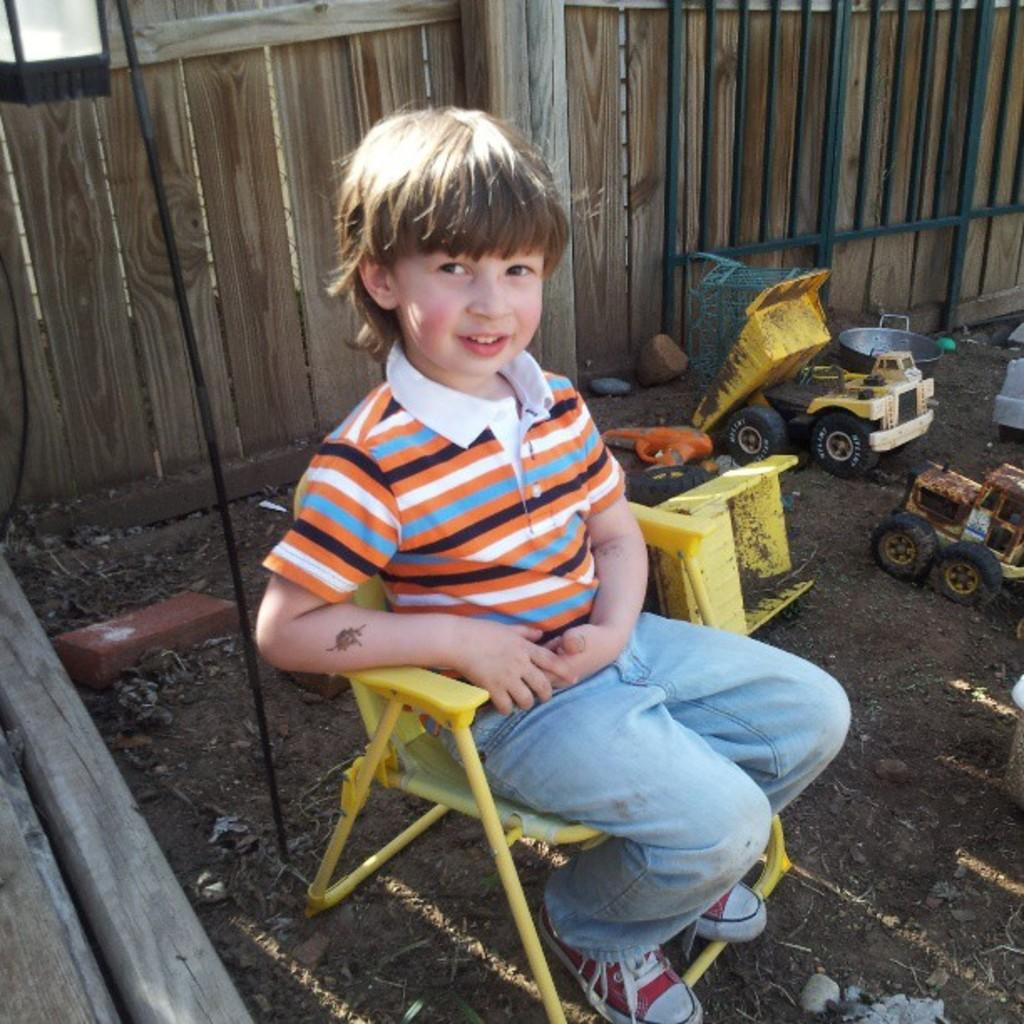What is the main subject of the image? The main subject of the image is a kid. What type of clothing is the kid wearing? The kid is wearing blue jeans. What is the kid sitting on in the image? The kid is sitting in a yellow chair. What can be seen on the ground near the kid? There are toys on the ground beside the kid. What type of barrier is visible in the background of the image? The background of the image includes a wooden fence. What is the kid's income in the image? The image does not provide information about the kid's income, as it is not relevant to the visual content. 